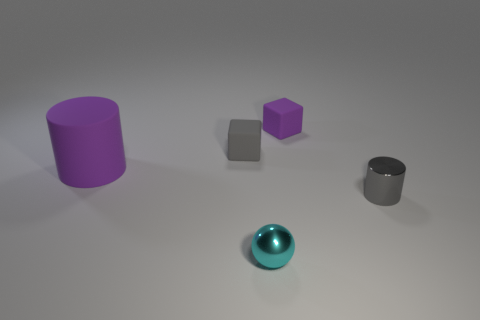Is there any other thing that is the same size as the matte cylinder? While the matte cylinder is unique in its dimensions, the purple cube appears to be similar in one dimension but is not identical in size. Objects in the given image vary in shape and size, making each distinct. 